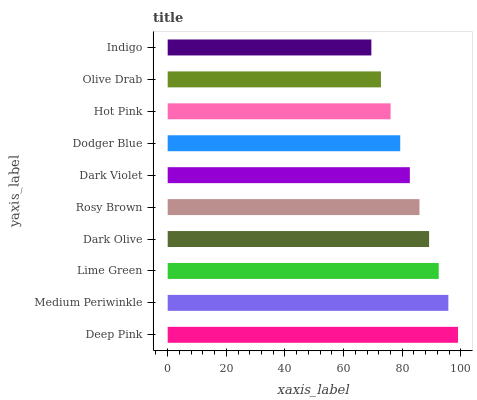Is Indigo the minimum?
Answer yes or no. Yes. Is Deep Pink the maximum?
Answer yes or no. Yes. Is Medium Periwinkle the minimum?
Answer yes or no. No. Is Medium Periwinkle the maximum?
Answer yes or no. No. Is Deep Pink greater than Medium Periwinkle?
Answer yes or no. Yes. Is Medium Periwinkle less than Deep Pink?
Answer yes or no. Yes. Is Medium Periwinkle greater than Deep Pink?
Answer yes or no. No. Is Deep Pink less than Medium Periwinkle?
Answer yes or no. No. Is Rosy Brown the high median?
Answer yes or no. Yes. Is Dark Violet the low median?
Answer yes or no. Yes. Is Olive Drab the high median?
Answer yes or no. No. Is Lime Green the low median?
Answer yes or no. No. 